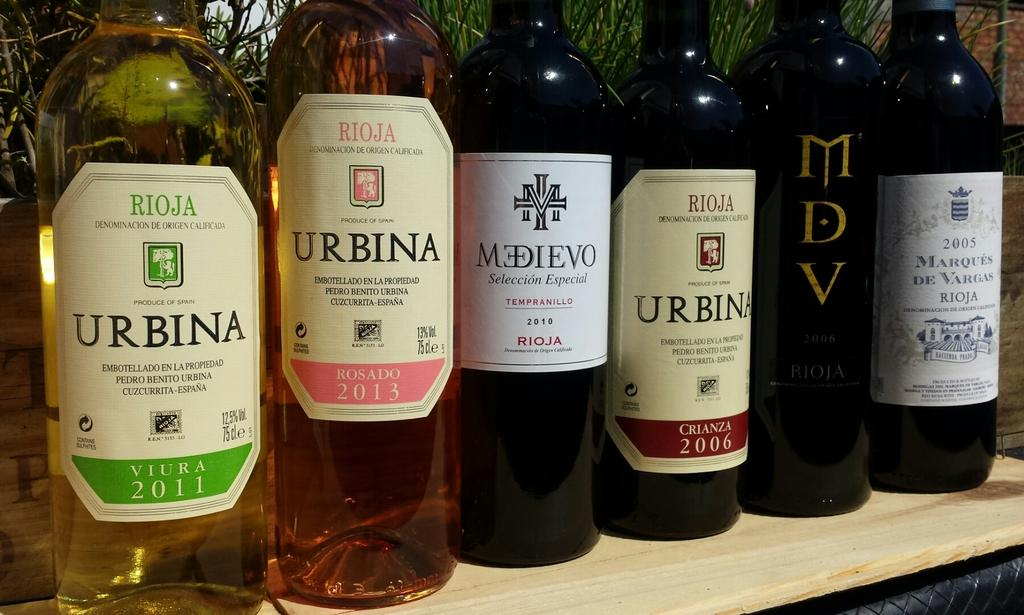How many bottles of RIOJA are in the image? There are six bottles of RIOJA in the image. Where are the bottles placed? The bottles are placed on a wooden table. What can be seen in the background of the image? There is grass, a brick wall, and a pole visible in the background of the image. What riddle is being solved by the bottles in the image? There is no riddle being solved by the bottles in the image; they are simply bottles placed on a table. 